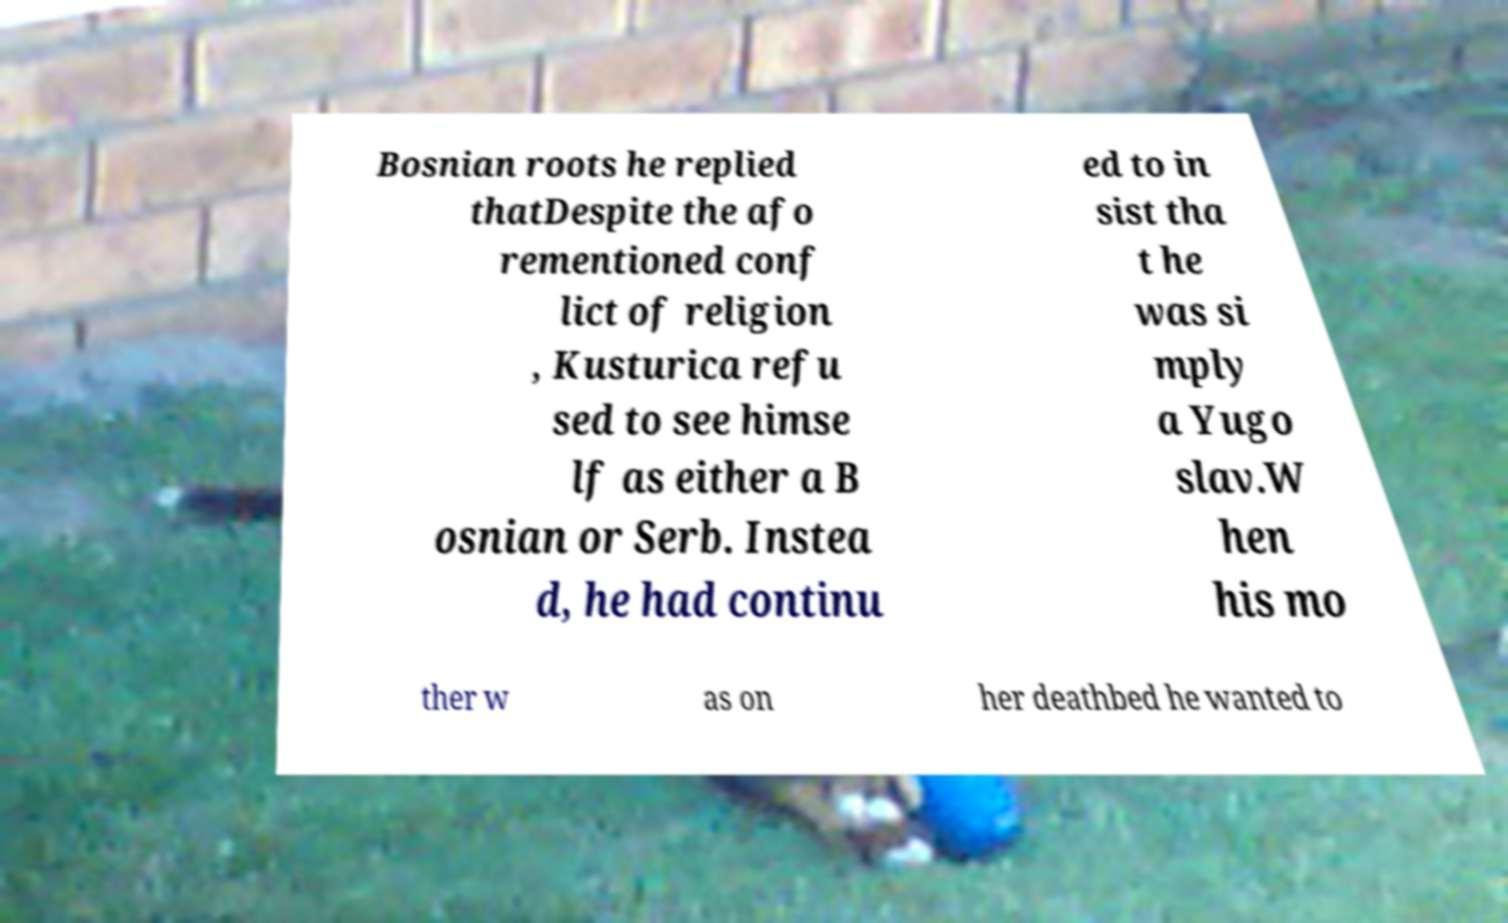Can you read and provide the text displayed in the image?This photo seems to have some interesting text. Can you extract and type it out for me? Bosnian roots he replied thatDespite the afo rementioned conf lict of religion , Kusturica refu sed to see himse lf as either a B osnian or Serb. Instea d, he had continu ed to in sist tha t he was si mply a Yugo slav.W hen his mo ther w as on her deathbed he wanted to 